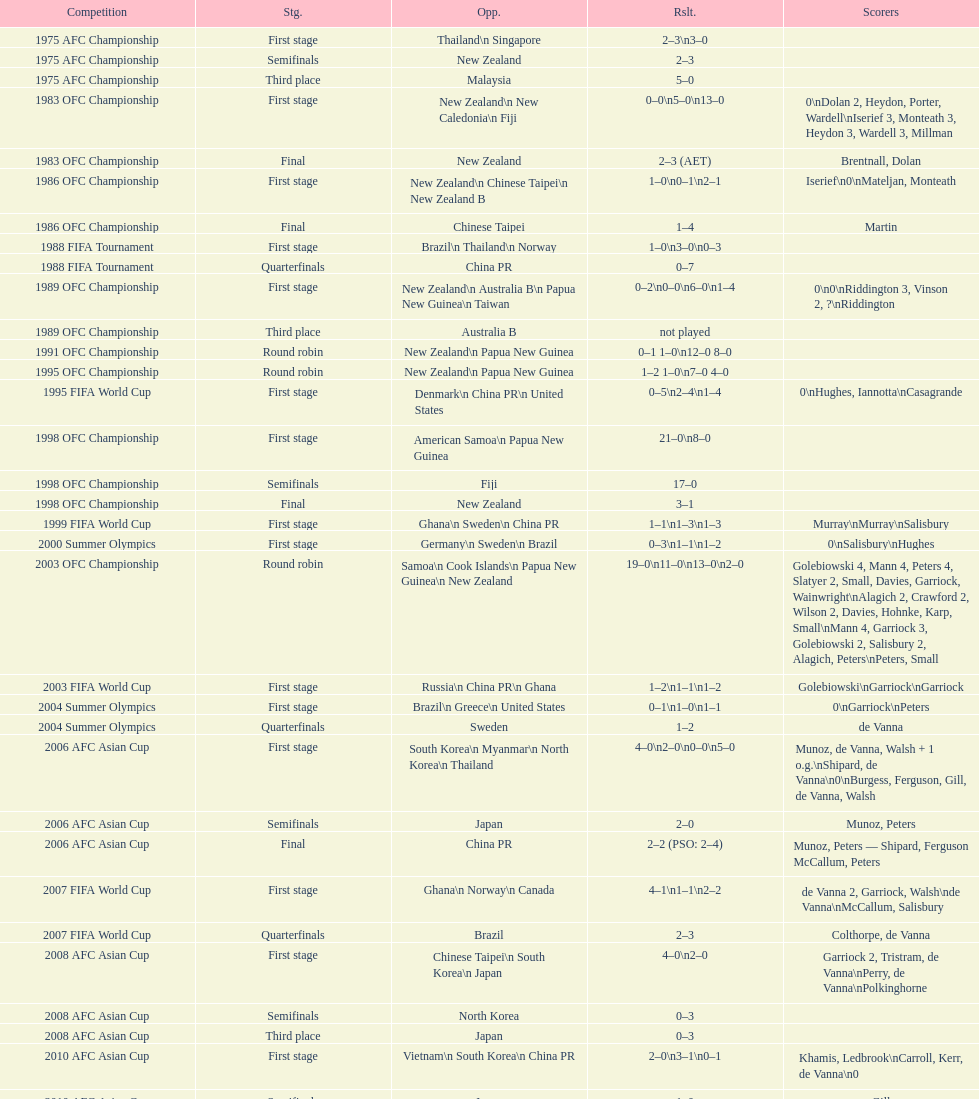How many players scored during the 1983 ofc championship competition? 9. Parse the full table. {'header': ['Competition', 'Stg.', 'Opp.', 'Rslt.', 'Scorers'], 'rows': [['1975 AFC Championship', 'First stage', 'Thailand\\n\xa0Singapore', '2–3\\n3–0', ''], ['1975 AFC Championship', 'Semifinals', 'New Zealand', '2–3', ''], ['1975 AFC Championship', 'Third place', 'Malaysia', '5–0', ''], ['1983 OFC Championship', 'First stage', 'New Zealand\\n\xa0New Caledonia\\n\xa0Fiji', '0–0\\n5–0\\n13–0', '0\\nDolan 2, Heydon, Porter, Wardell\\nIserief 3, Monteath 3, Heydon 3, Wardell 3, Millman'], ['1983 OFC Championship', 'Final', 'New Zealand', '2–3 (AET)', 'Brentnall, Dolan'], ['1986 OFC Championship', 'First stage', 'New Zealand\\n\xa0Chinese Taipei\\n New Zealand B', '1–0\\n0–1\\n2–1', 'Iserief\\n0\\nMateljan, Monteath'], ['1986 OFC Championship', 'Final', 'Chinese Taipei', '1–4', 'Martin'], ['1988 FIFA Tournament', 'First stage', 'Brazil\\n\xa0Thailand\\n\xa0Norway', '1–0\\n3–0\\n0–3', ''], ['1988 FIFA Tournament', 'Quarterfinals', 'China PR', '0–7', ''], ['1989 OFC Championship', 'First stage', 'New Zealand\\n Australia B\\n\xa0Papua New Guinea\\n\xa0Taiwan', '0–2\\n0–0\\n6–0\\n1–4', '0\\n0\\nRiddington 3, Vinson 2,\xa0?\\nRiddington'], ['1989 OFC Championship', 'Third place', 'Australia B', 'not played', ''], ['1991 OFC Championship', 'Round robin', 'New Zealand\\n\xa0Papua New Guinea', '0–1 1–0\\n12–0 8–0', ''], ['1995 OFC Championship', 'Round robin', 'New Zealand\\n\xa0Papua New Guinea', '1–2 1–0\\n7–0 4–0', ''], ['1995 FIFA World Cup', 'First stage', 'Denmark\\n\xa0China PR\\n\xa0United States', '0–5\\n2–4\\n1–4', '0\\nHughes, Iannotta\\nCasagrande'], ['1998 OFC Championship', 'First stage', 'American Samoa\\n\xa0Papua New Guinea', '21–0\\n8–0', ''], ['1998 OFC Championship', 'Semifinals', 'Fiji', '17–0', ''], ['1998 OFC Championship', 'Final', 'New Zealand', '3–1', ''], ['1999 FIFA World Cup', 'First stage', 'Ghana\\n\xa0Sweden\\n\xa0China PR', '1–1\\n1–3\\n1–3', 'Murray\\nMurray\\nSalisbury'], ['2000 Summer Olympics', 'First stage', 'Germany\\n\xa0Sweden\\n\xa0Brazil', '0–3\\n1–1\\n1–2', '0\\nSalisbury\\nHughes'], ['2003 OFC Championship', 'Round robin', 'Samoa\\n\xa0Cook Islands\\n\xa0Papua New Guinea\\n\xa0New Zealand', '19–0\\n11–0\\n13–0\\n2–0', 'Golebiowski 4, Mann 4, Peters 4, Slatyer 2, Small, Davies, Garriock, Wainwright\\nAlagich 2, Crawford 2, Wilson 2, Davies, Hohnke, Karp, Small\\nMann 4, Garriock 3, Golebiowski 2, Salisbury 2, Alagich, Peters\\nPeters, Small'], ['2003 FIFA World Cup', 'First stage', 'Russia\\n\xa0China PR\\n\xa0Ghana', '1–2\\n1–1\\n1–2', 'Golebiowski\\nGarriock\\nGarriock'], ['2004 Summer Olympics', 'First stage', 'Brazil\\n\xa0Greece\\n\xa0United States', '0–1\\n1–0\\n1–1', '0\\nGarriock\\nPeters'], ['2004 Summer Olympics', 'Quarterfinals', 'Sweden', '1–2', 'de Vanna'], ['2006 AFC Asian Cup', 'First stage', 'South Korea\\n\xa0Myanmar\\n\xa0North Korea\\n\xa0Thailand', '4–0\\n2–0\\n0–0\\n5–0', 'Munoz, de Vanna, Walsh + 1 o.g.\\nShipard, de Vanna\\n0\\nBurgess, Ferguson, Gill, de Vanna, Walsh'], ['2006 AFC Asian Cup', 'Semifinals', 'Japan', '2–0', 'Munoz, Peters'], ['2006 AFC Asian Cup', 'Final', 'China PR', '2–2 (PSO: 2–4)', 'Munoz, Peters — Shipard, Ferguson McCallum, Peters'], ['2007 FIFA World Cup', 'First stage', 'Ghana\\n\xa0Norway\\n\xa0Canada', '4–1\\n1–1\\n2–2', 'de Vanna 2, Garriock, Walsh\\nde Vanna\\nMcCallum, Salisbury'], ['2007 FIFA World Cup', 'Quarterfinals', 'Brazil', '2–3', 'Colthorpe, de Vanna'], ['2008 AFC Asian Cup', 'First stage', 'Chinese Taipei\\n\xa0South Korea\\n\xa0Japan', '4–0\\n2–0', 'Garriock 2, Tristram, de Vanna\\nPerry, de Vanna\\nPolkinghorne'], ['2008 AFC Asian Cup', 'Semifinals', 'North Korea', '0–3', ''], ['2008 AFC Asian Cup', 'Third place', 'Japan', '0–3', ''], ['2010 AFC Asian Cup', 'First stage', 'Vietnam\\n\xa0South Korea\\n\xa0China PR', '2–0\\n3–1\\n0–1', 'Khamis, Ledbrook\\nCarroll, Kerr, de Vanna\\n0'], ['2010 AFC Asian Cup', 'Semifinals', 'Japan', '1–0', 'Gill'], ['2010 AFC Asian Cup', 'Final', 'North Korea', '1–1 (PSO: 5–4)', 'Kerr — PSO: Shipard, Ledbrook, Gill, Garriock, Simon'], ['2011 FIFA World Cup', 'First stage', 'Brazil\\n\xa0Equatorial Guinea\\n\xa0Norway', '0–1\\n3–2\\n2–1', '0\\nvan Egmond, Khamis, de Vanna\\nSimon 2'], ['2011 FIFA World Cup', 'Quarterfinals', 'Sweden', '1–3', 'Perry'], ['2012 Summer Olympics\\nAFC qualification', 'Final round', 'North Korea\\n\xa0Thailand\\n\xa0Japan\\n\xa0China PR\\n\xa0South Korea', '0–1\\n5–1\\n0–1\\n1–0\\n2–1', '0\\nHeyman 2, Butt, van Egmond, Simon\\n0\\nvan Egmond\\nButt, de Vanna'], ['2014 AFC Asian Cup', 'First stage', 'Japan\\n\xa0Jordan\\n\xa0Vietnam', 'TBD\\nTBD\\nTBD', '']]} 